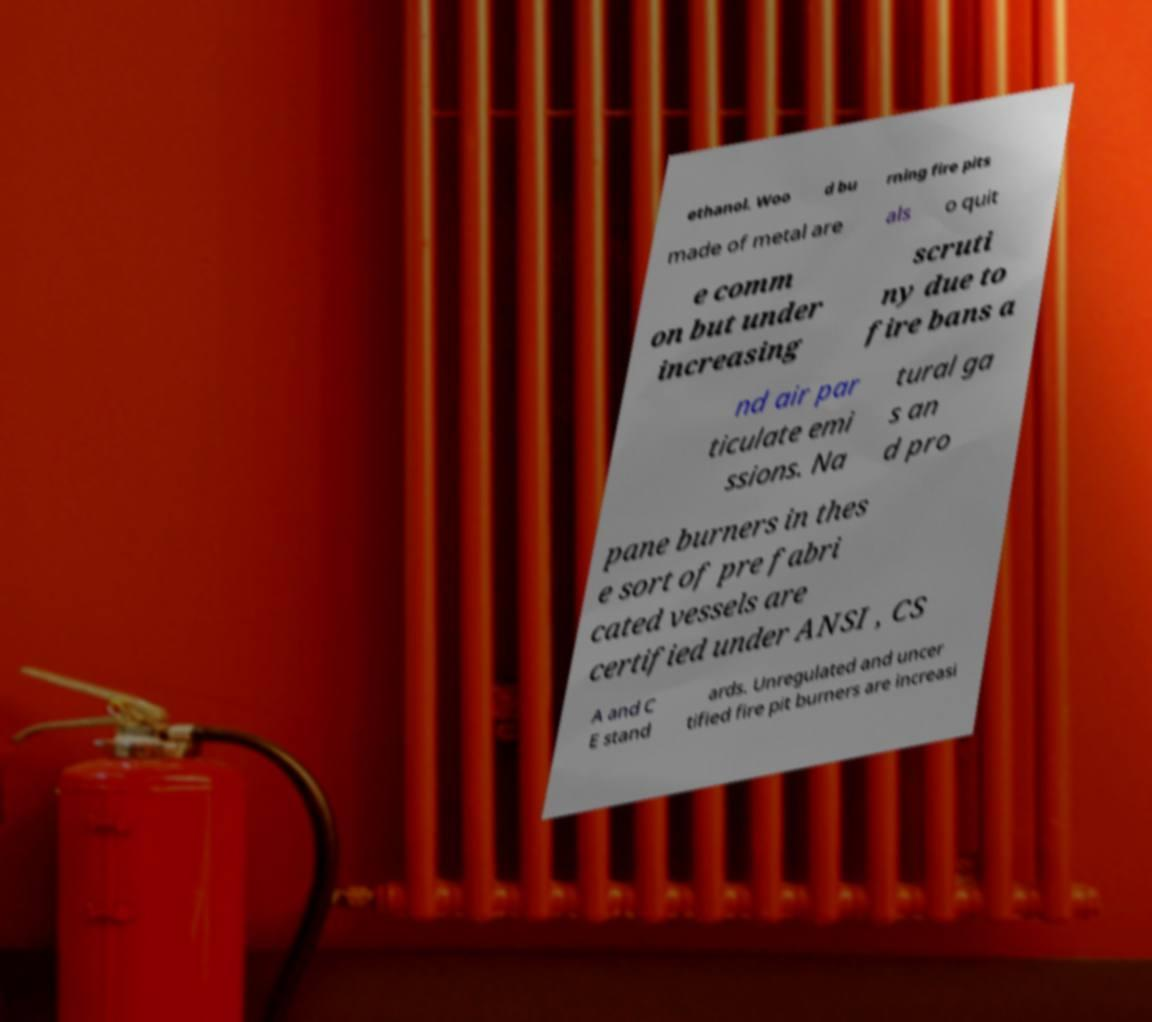Can you read and provide the text displayed in the image?This photo seems to have some interesting text. Can you extract and type it out for me? ethanol. Woo d bu rning fire pits made of metal are als o quit e comm on but under increasing scruti ny due to fire bans a nd air par ticulate emi ssions. Na tural ga s an d pro pane burners in thes e sort of pre fabri cated vessels are certified under ANSI , CS A and C E stand ards. Unregulated and uncer tified fire pit burners are increasi 